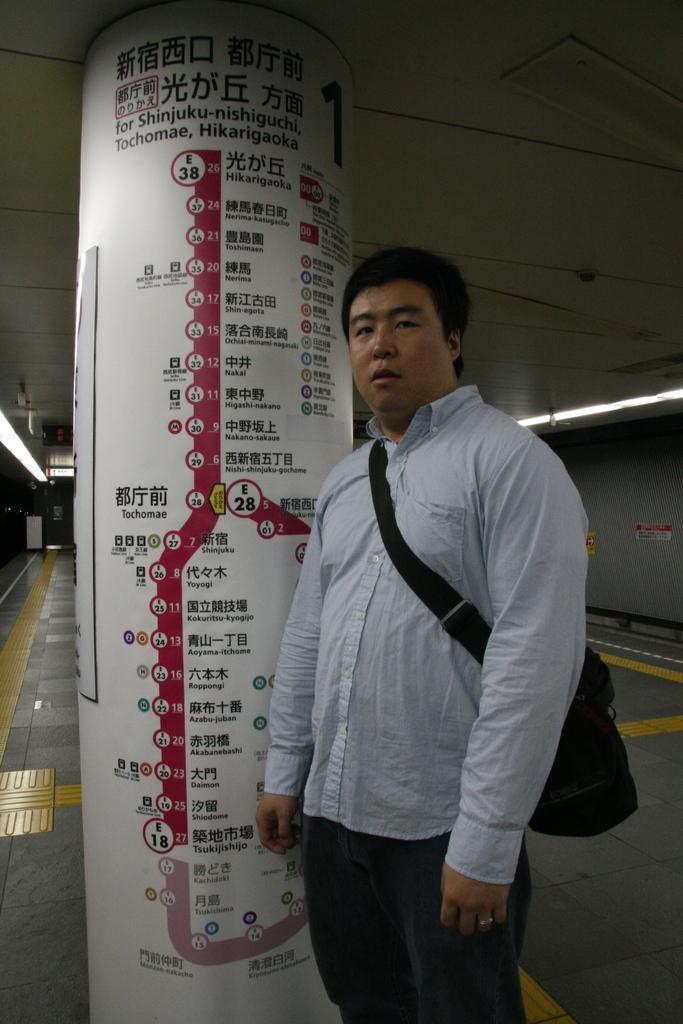Who is present in the image? There is a person in the image. What is the person holding or carrying? The person is carrying a bag. Where is the person standing? The person is standing on the floor. What can be seen in the background of the image? There is a wall with some text on it and lights visible in the background. What type of thunder can be heard in the image? There is no sound present in the image, so it is not possible to determine if thunder can be heard. 